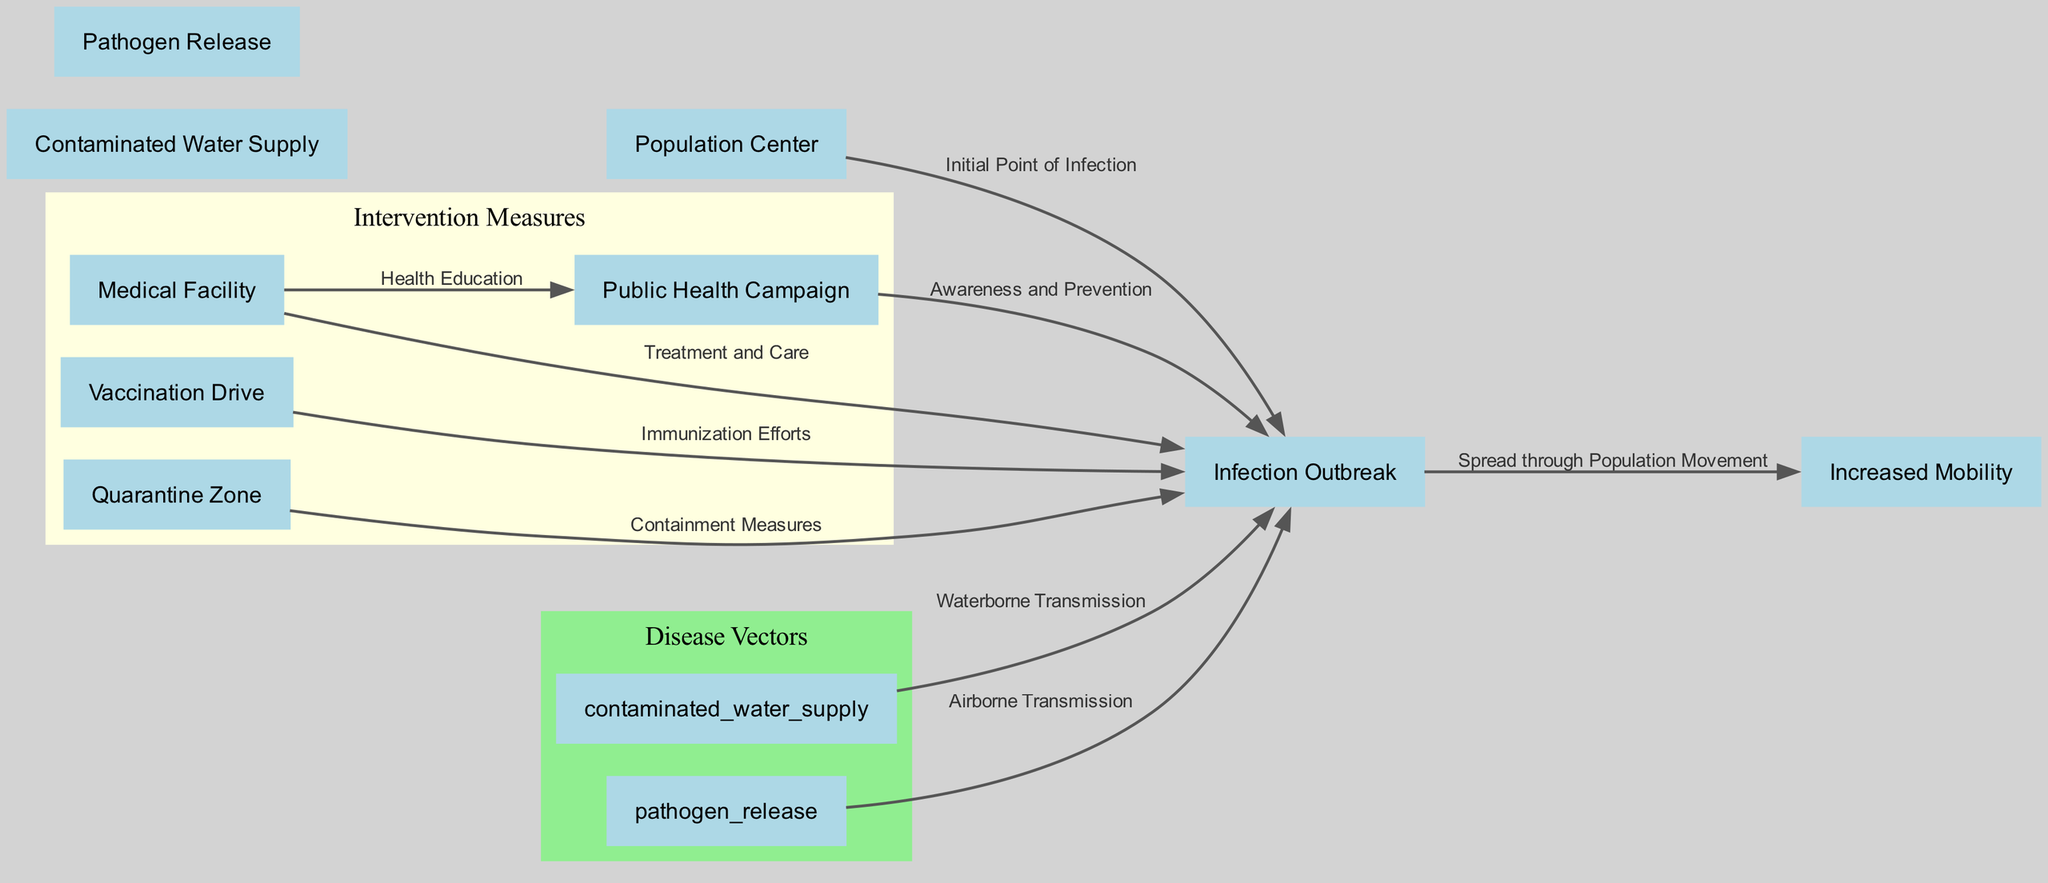What is the initial point of infection? The diagram indicates that the initial point of infection is the "Population Center." This is the first node in the flow, showing where the infection initially arises.
Answer: Population Center How many intervention measures are present in the diagram? The diagram lists four intervention measures: Medical Facility, Public Health Campaign, Vaccination Drive, and Quarantine Zone. Counting these nodes gives us the total number of measures.
Answer: 4 What does the edge labeled "Waterborne Transmission" connect? This edge connects "Contaminated Water Supply" to "Infection Outbreak." The label shows the type of transmission that leads to the infection.
Answer: Contaminated Water Supply and Infection Outbreak Which nodes are part of the containment measures? The nodes part of the containment measures include "Quarantine Zone" and "Medical Facility." These measures are aimed at controlling and treating the infection outbreak.
Answer: Quarantine Zone, Medical Facility What is the relationship between "Medical Facility" and "Public Health Campaign"? The relationship is one of health education; the Medical Facility supports the Public Health Campaign to provide necessary health education to the population in the areas impacted by the disease.
Answer: Health Education What is the primary effect of the edge labeled "Spread through Population Movement"? This edge shows that the Infection Outbreak is influenced by increased mobility among the population, indicating that as people move, the infection spreads more.
Answer: Spread through Population Movement How many total nodes are present in the diagram? By counting each unique node listed, we find that there are a total of 9 nodes represented in the diagram, which includes both the factors contributing to the infection and the intervention points.
Answer: 9 Which edge indicates airborne transmission? The edge labeled "Airborne Transmission" connects "Pathogen Release" to "Infection Outbreak." This connection signifies that pathogens released into the air can lead to infection outbreaks.
Answer: Pathogen Release to Infection Outbreak What intervention aims to provide immunization efforts? The node "Vaccination Drive" is specifically aimed at immunization efforts to prevent the spread of infectious diseases in disaster-stricken areas.
Answer: Vaccination Drive 